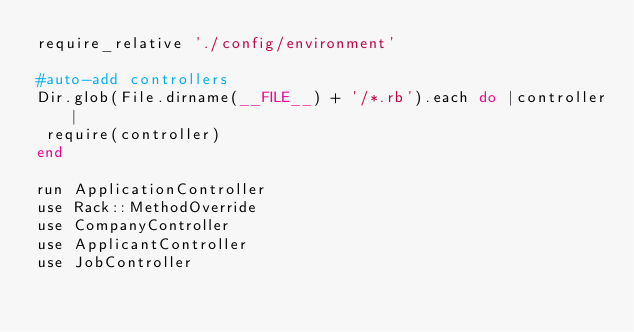<code> <loc_0><loc_0><loc_500><loc_500><_Ruby_>require_relative './config/environment'

#auto-add controllers
Dir.glob(File.dirname(__FILE__) + '/*.rb').each do |controller|
 require(controller)
end

run ApplicationController
use Rack::MethodOverride
use CompanyController
use ApplicantController
use JobController
</code> 